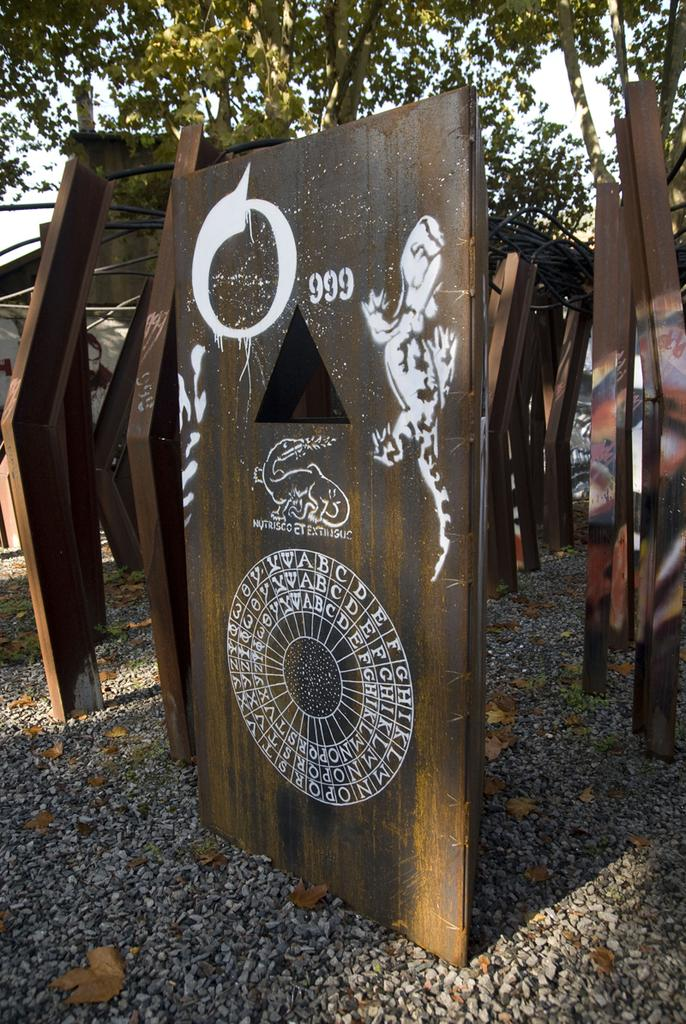What type of material is featured in the image? There are wooden planks in the image. What is the wooden planks resting on? The wooden planks are on a stone surface. What can be seen in the background of the image? There are trees visible in the background of the image. How does the rose move in the image? There is no rose present in the image, so it cannot move. 